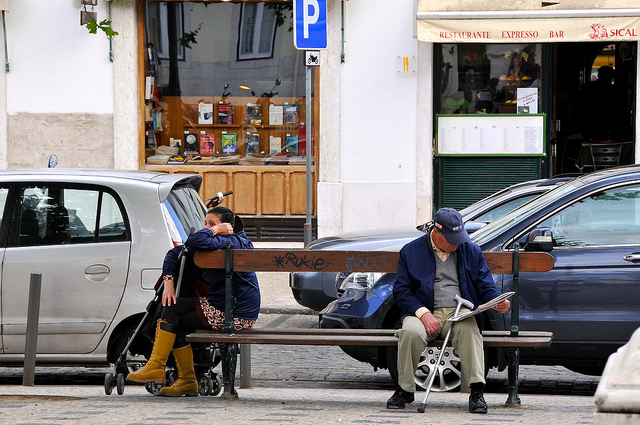Read and extract the text from this image. EXPRESSO SICAL P Rukie 